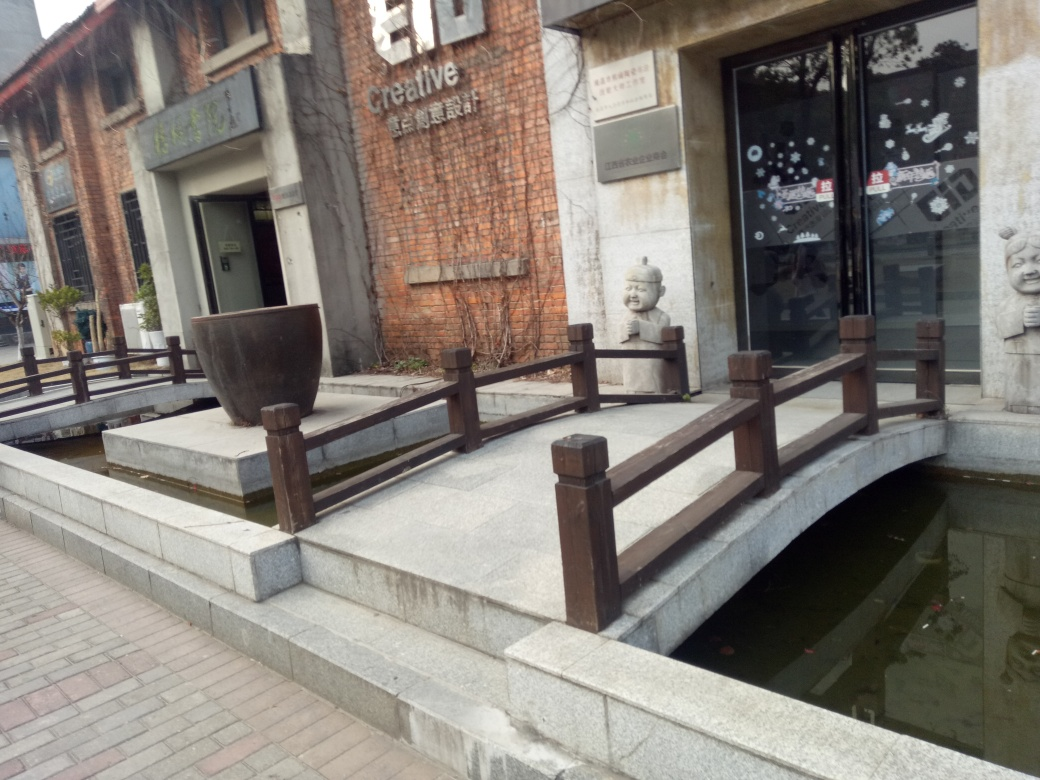Could you describe the architectural style visible in the image? The architectural style in the image is a fusion of traditional and modern elements. The building features a weathered brick facade that suggests a historical or industrial past, while the incorporation of clean lines and modern art installations, including the sculpted faces by the entrance, add a contemporary feel. The bridge with its wooden railing could be a nod to traditional construction methods. The overall style promotes a blend of the new with the old, creating a unique and creative atmosphere. 